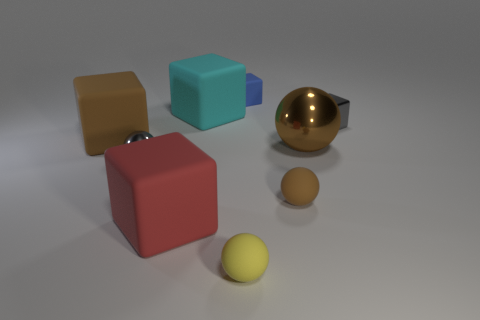How many brown spheres must be subtracted to get 1 brown spheres? 1 Subtract all tiny shiny cubes. How many cubes are left? 4 Subtract all cubes. How many objects are left? 4 Subtract 1 cubes. How many cubes are left? 4 Subtract all cyan blocks. How many blocks are left? 4 Subtract all red balls. Subtract all cyan blocks. How many balls are left? 4 Subtract all green blocks. How many gray spheres are left? 1 Subtract all tiny spheres. Subtract all small cyan matte things. How many objects are left? 6 Add 3 small metal spheres. How many small metal spheres are left? 4 Add 3 tiny balls. How many tiny balls exist? 6 